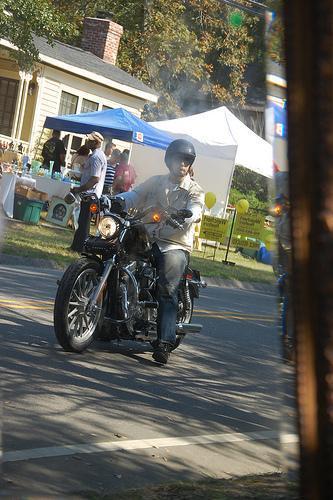How many motorcycles are there?
Give a very brief answer. 1. 